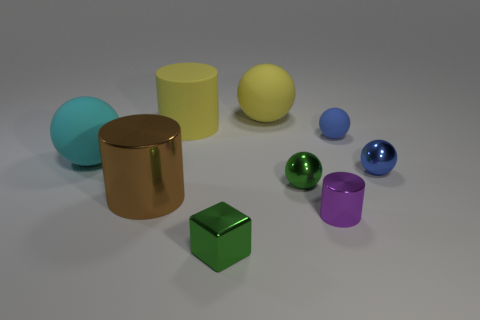What shape are the objects, and how many of each shape are present? In the image, there are cylindrical shapes (two), spherical objects (four), and one cubical shape. 